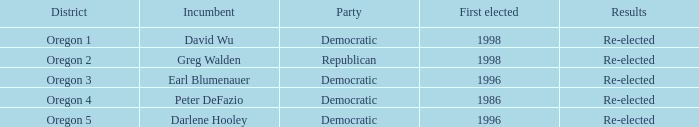What was the result of the Oregon 5 District incumbent who was first elected in 1996? Re-elected. 